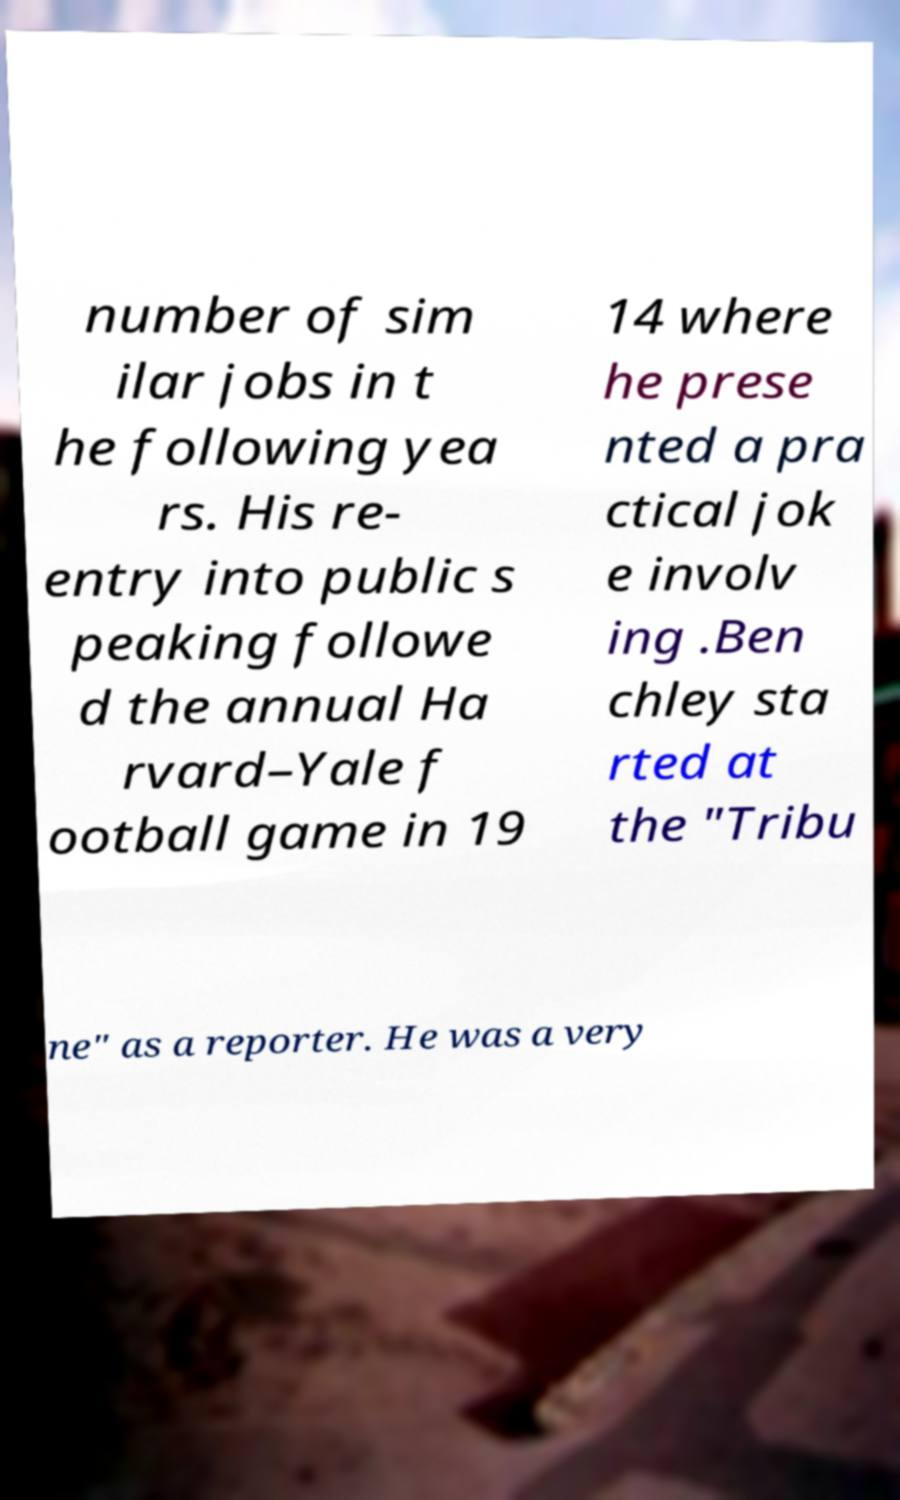Could you extract and type out the text from this image? number of sim ilar jobs in t he following yea rs. His re- entry into public s peaking followe d the annual Ha rvard–Yale f ootball game in 19 14 where he prese nted a pra ctical jok e involv ing .Ben chley sta rted at the "Tribu ne" as a reporter. He was a very 